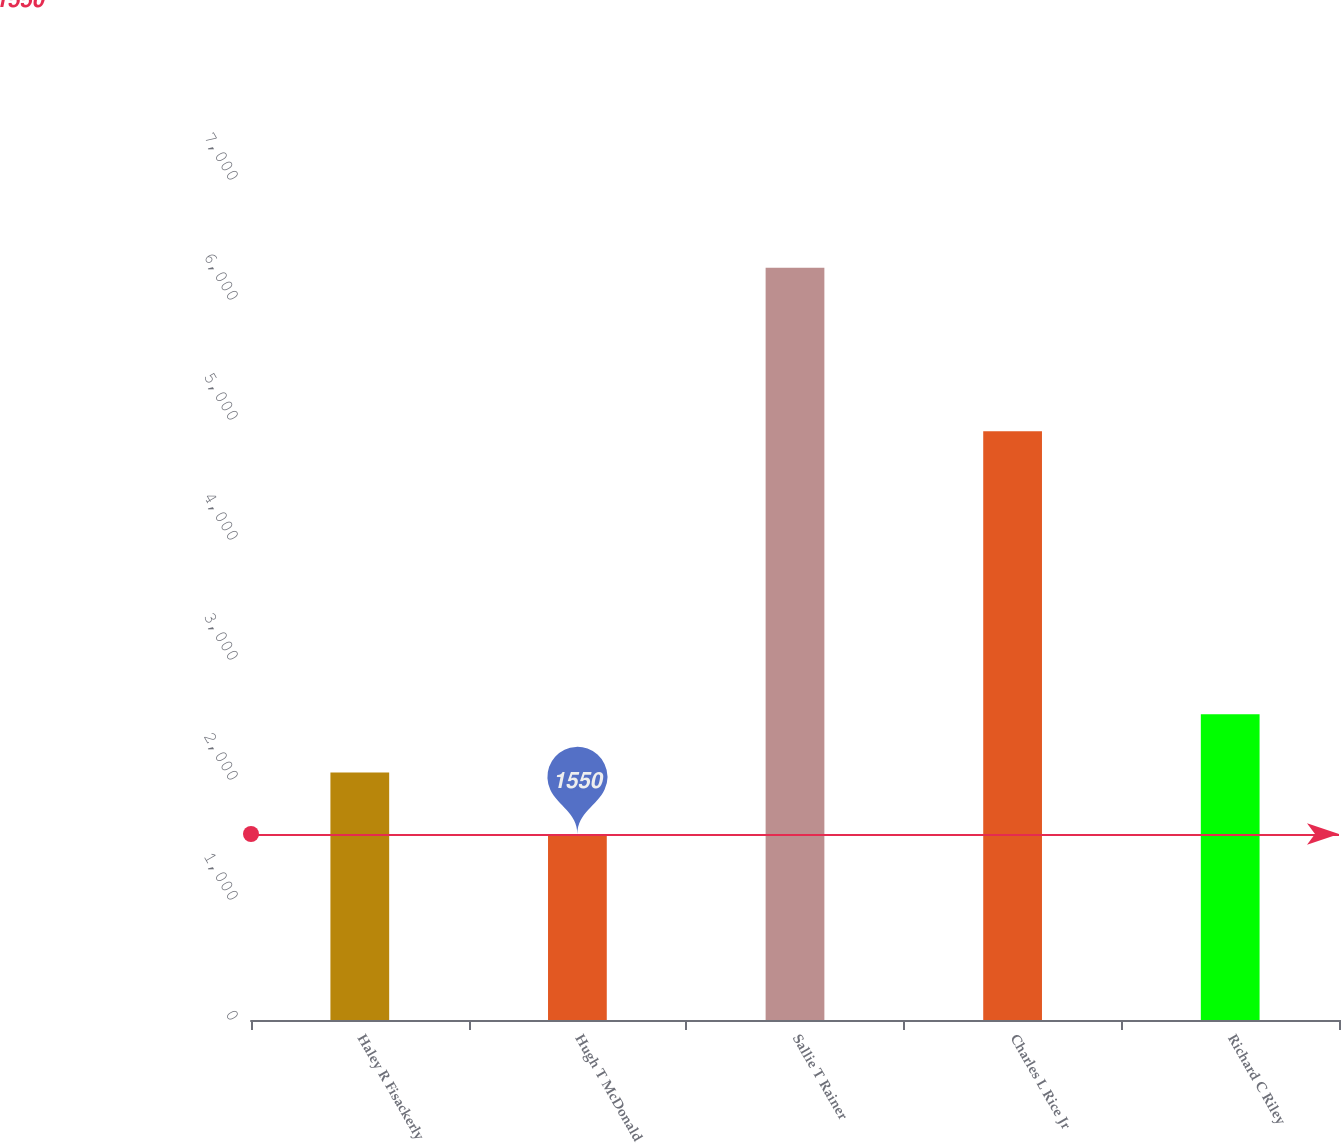Convert chart to OTSL. <chart><loc_0><loc_0><loc_500><loc_500><bar_chart><fcel>Haley R Fisackerly<fcel>Hugh T McDonald<fcel>Sallie T Rainer<fcel>Charles L Rice Jr<fcel>Richard C Riley<nl><fcel>2062<fcel>1550<fcel>6268<fcel>4907<fcel>2548<nl></chart> 